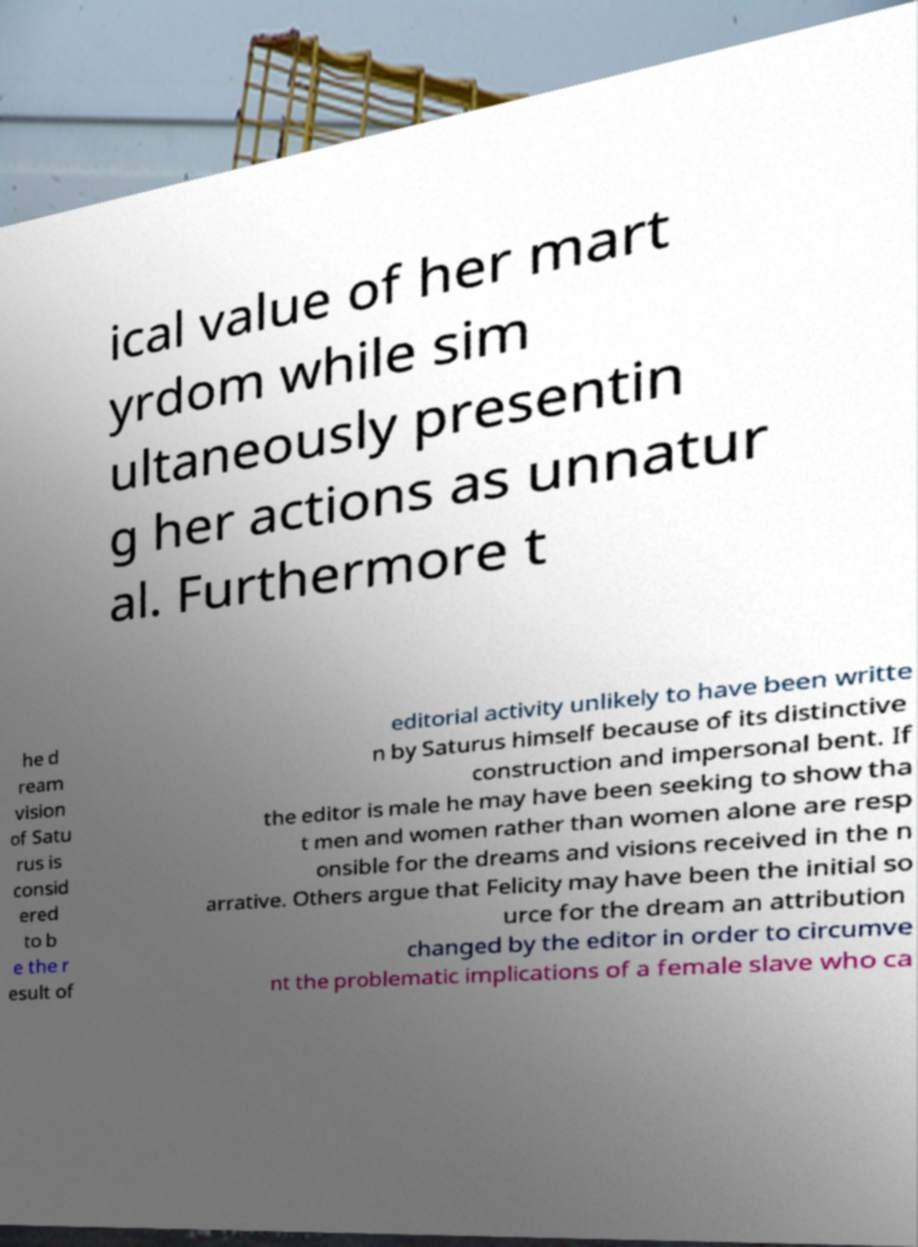What messages or text are displayed in this image? I need them in a readable, typed format. ical value of her mart yrdom while sim ultaneously presentin g her actions as unnatur al. Furthermore t he d ream vision of Satu rus is consid ered to b e the r esult of editorial activity unlikely to have been writte n by Saturus himself because of its distinctive construction and impersonal bent. If the editor is male he may have been seeking to show tha t men and women rather than women alone are resp onsible for the dreams and visions received in the n arrative. Others argue that Felicity may have been the initial so urce for the dream an attribution changed by the editor in order to circumve nt the problematic implications of a female slave who ca 